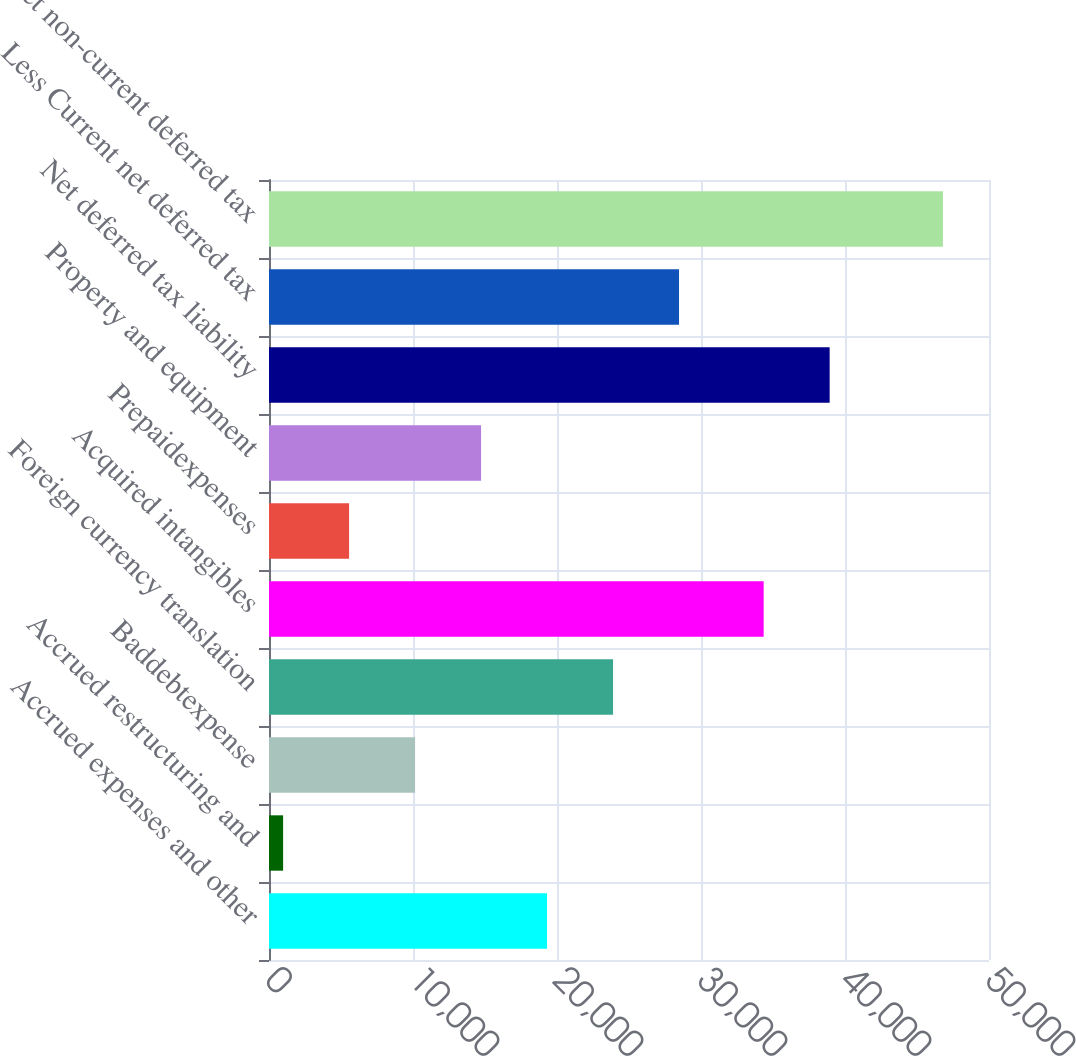Convert chart. <chart><loc_0><loc_0><loc_500><loc_500><bar_chart><fcel>Accrued expenses and other<fcel>Accrued restructuring and<fcel>Baddebtexpense<fcel>Foreign currency translation<fcel>Acquired intangibles<fcel>Prepaidexpenses<fcel>Property and equipment<fcel>Net deferred tax liability<fcel>Less Current net deferred tax<fcel>Net non-current deferred tax<nl><fcel>19309.6<fcel>980<fcel>10144.8<fcel>23892<fcel>34352<fcel>5562.4<fcel>14727.2<fcel>38934.4<fcel>28474.4<fcel>46804<nl></chart> 